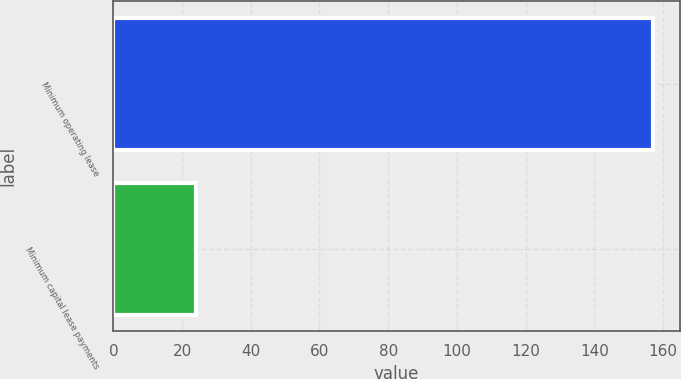Convert chart to OTSL. <chart><loc_0><loc_0><loc_500><loc_500><bar_chart><fcel>Minimum operating lease<fcel>Minimum capital lease payments<nl><fcel>157<fcel>24<nl></chart> 